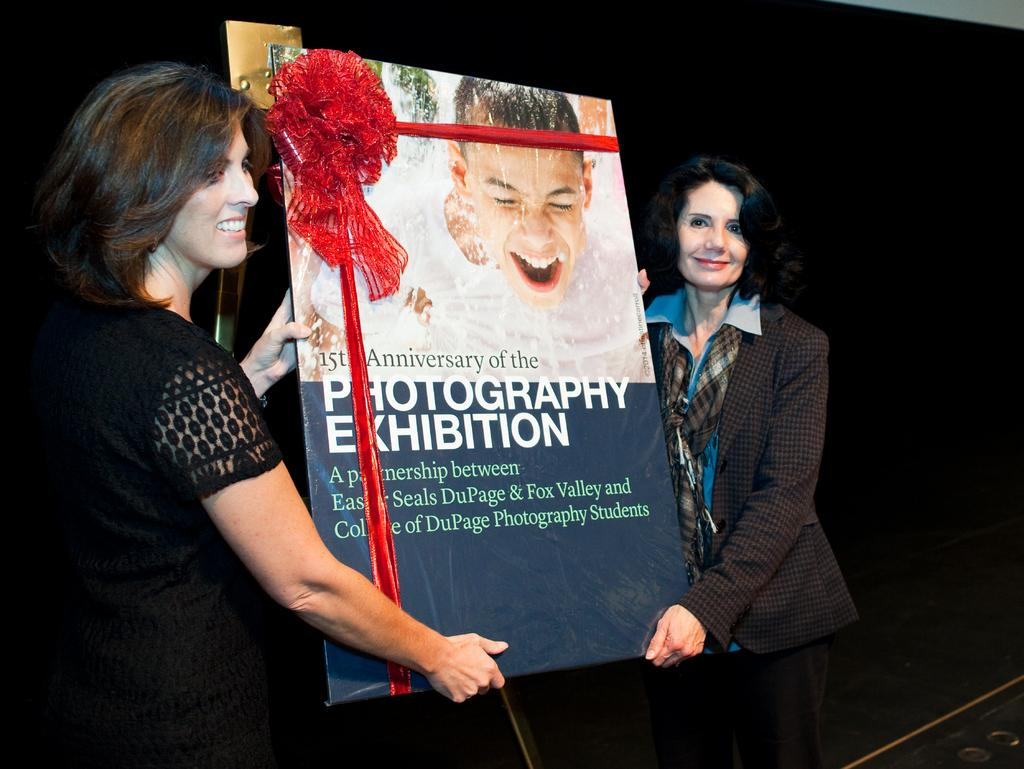How many people are in the image? There are two women in the image. Where are the women located in the image? The women are standing in the center of the image. What are the women holding in the image? The women are holding a board. What is written or displayed on the board? There is text on the board. What decorative element is present on the board? There is a ribbon on the board. How does the girl in the image maintain her quiet demeanor? There is no girl present in the image; it features two women. 